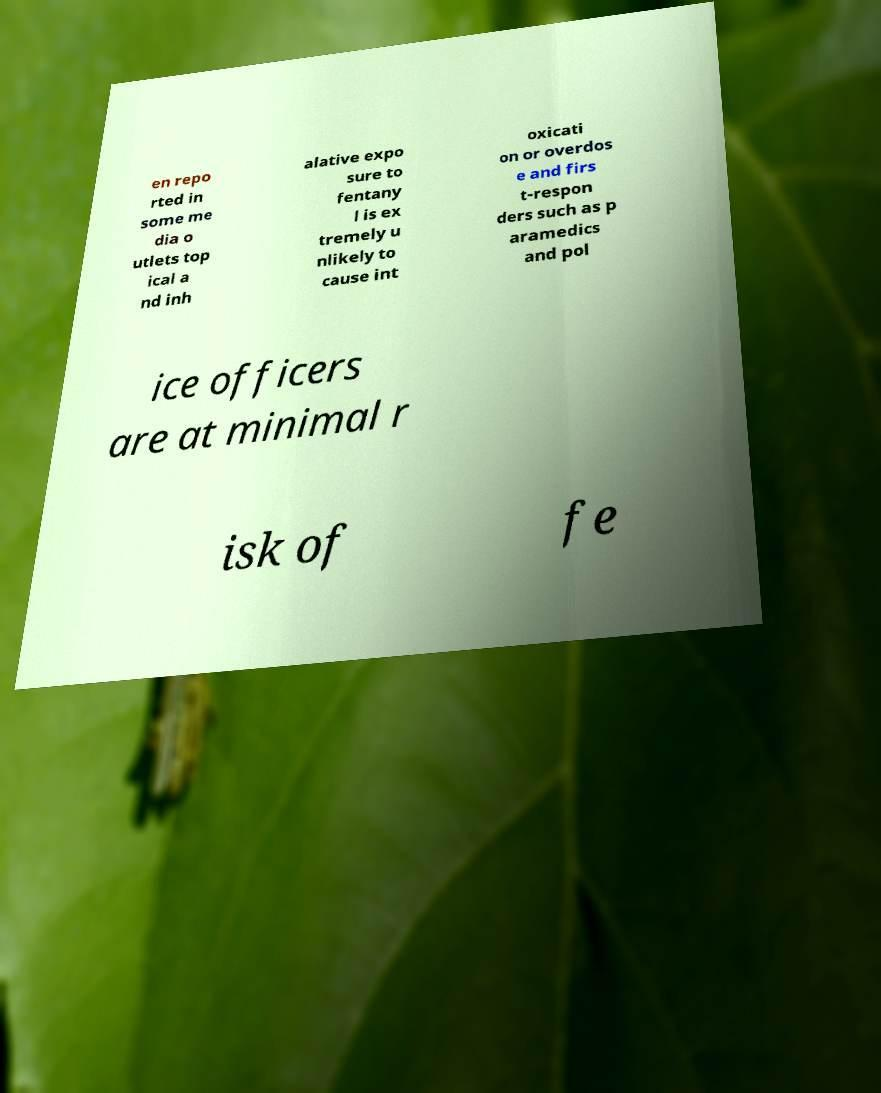I need the written content from this picture converted into text. Can you do that? en repo rted in some me dia o utlets top ical a nd inh alative expo sure to fentany l is ex tremely u nlikely to cause int oxicati on or overdos e and firs t-respon ders such as p aramedics and pol ice officers are at minimal r isk of fe 